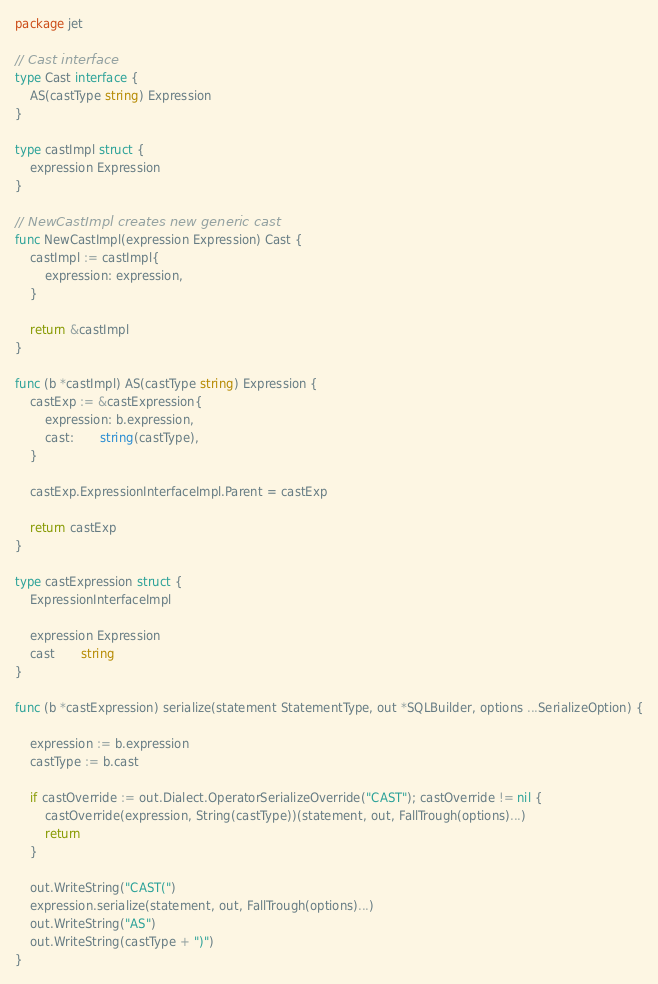<code> <loc_0><loc_0><loc_500><loc_500><_Go_>package jet

// Cast interface
type Cast interface {
	AS(castType string) Expression
}

type castImpl struct {
	expression Expression
}

// NewCastImpl creates new generic cast
func NewCastImpl(expression Expression) Cast {
	castImpl := castImpl{
		expression: expression,
	}

	return &castImpl
}

func (b *castImpl) AS(castType string) Expression {
	castExp := &castExpression{
		expression: b.expression,
		cast:       string(castType),
	}

	castExp.ExpressionInterfaceImpl.Parent = castExp

	return castExp
}

type castExpression struct {
	ExpressionInterfaceImpl

	expression Expression
	cast       string
}

func (b *castExpression) serialize(statement StatementType, out *SQLBuilder, options ...SerializeOption) {

	expression := b.expression
	castType := b.cast

	if castOverride := out.Dialect.OperatorSerializeOverride("CAST"); castOverride != nil {
		castOverride(expression, String(castType))(statement, out, FallTrough(options)...)
		return
	}

	out.WriteString("CAST(")
	expression.serialize(statement, out, FallTrough(options)...)
	out.WriteString("AS")
	out.WriteString(castType + ")")
}
</code> 